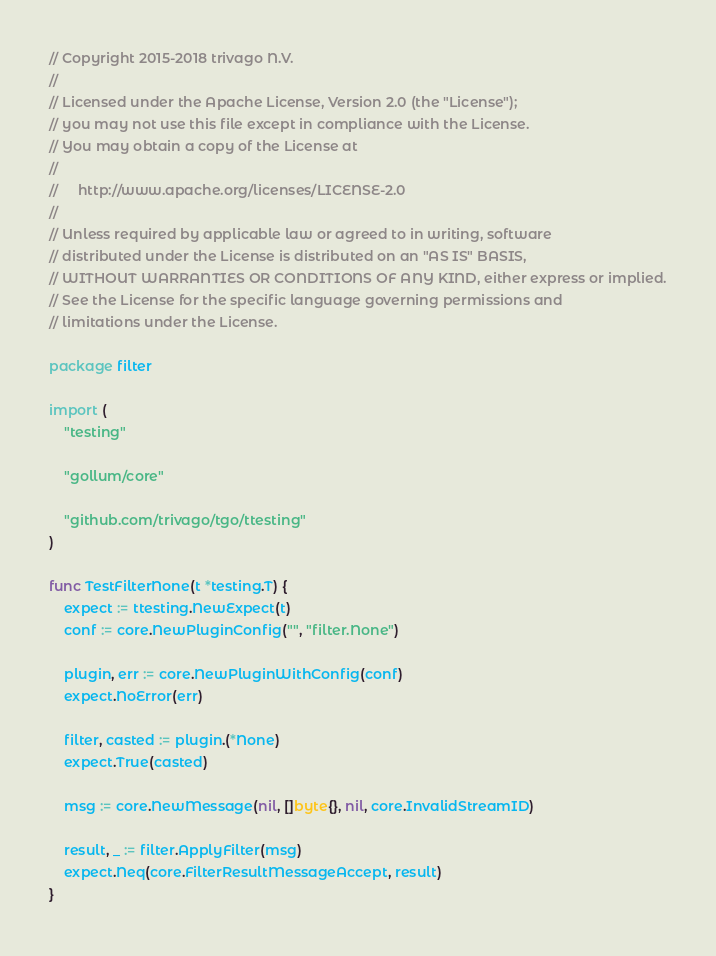Convert code to text. <code><loc_0><loc_0><loc_500><loc_500><_Go_>// Copyright 2015-2018 trivago N.V.
//
// Licensed under the Apache License, Version 2.0 (the "License");
// you may not use this file except in compliance with the License.
// You may obtain a copy of the License at
//
//     http://www.apache.org/licenses/LICENSE-2.0
//
// Unless required by applicable law or agreed to in writing, software
// distributed under the License is distributed on an "AS IS" BASIS,
// WITHOUT WARRANTIES OR CONDITIONS OF ANY KIND, either express or implied.
// See the License for the specific language governing permissions and
// limitations under the License.

package filter

import (
	"testing"

	"gollum/core"

	"github.com/trivago/tgo/ttesting"
)

func TestFilterNone(t *testing.T) {
	expect := ttesting.NewExpect(t)
	conf := core.NewPluginConfig("", "filter.None")

	plugin, err := core.NewPluginWithConfig(conf)
	expect.NoError(err)

	filter, casted := plugin.(*None)
	expect.True(casted)

	msg := core.NewMessage(nil, []byte{}, nil, core.InvalidStreamID)

	result, _ := filter.ApplyFilter(msg)
	expect.Neq(core.FilterResultMessageAccept, result)
}
</code> 